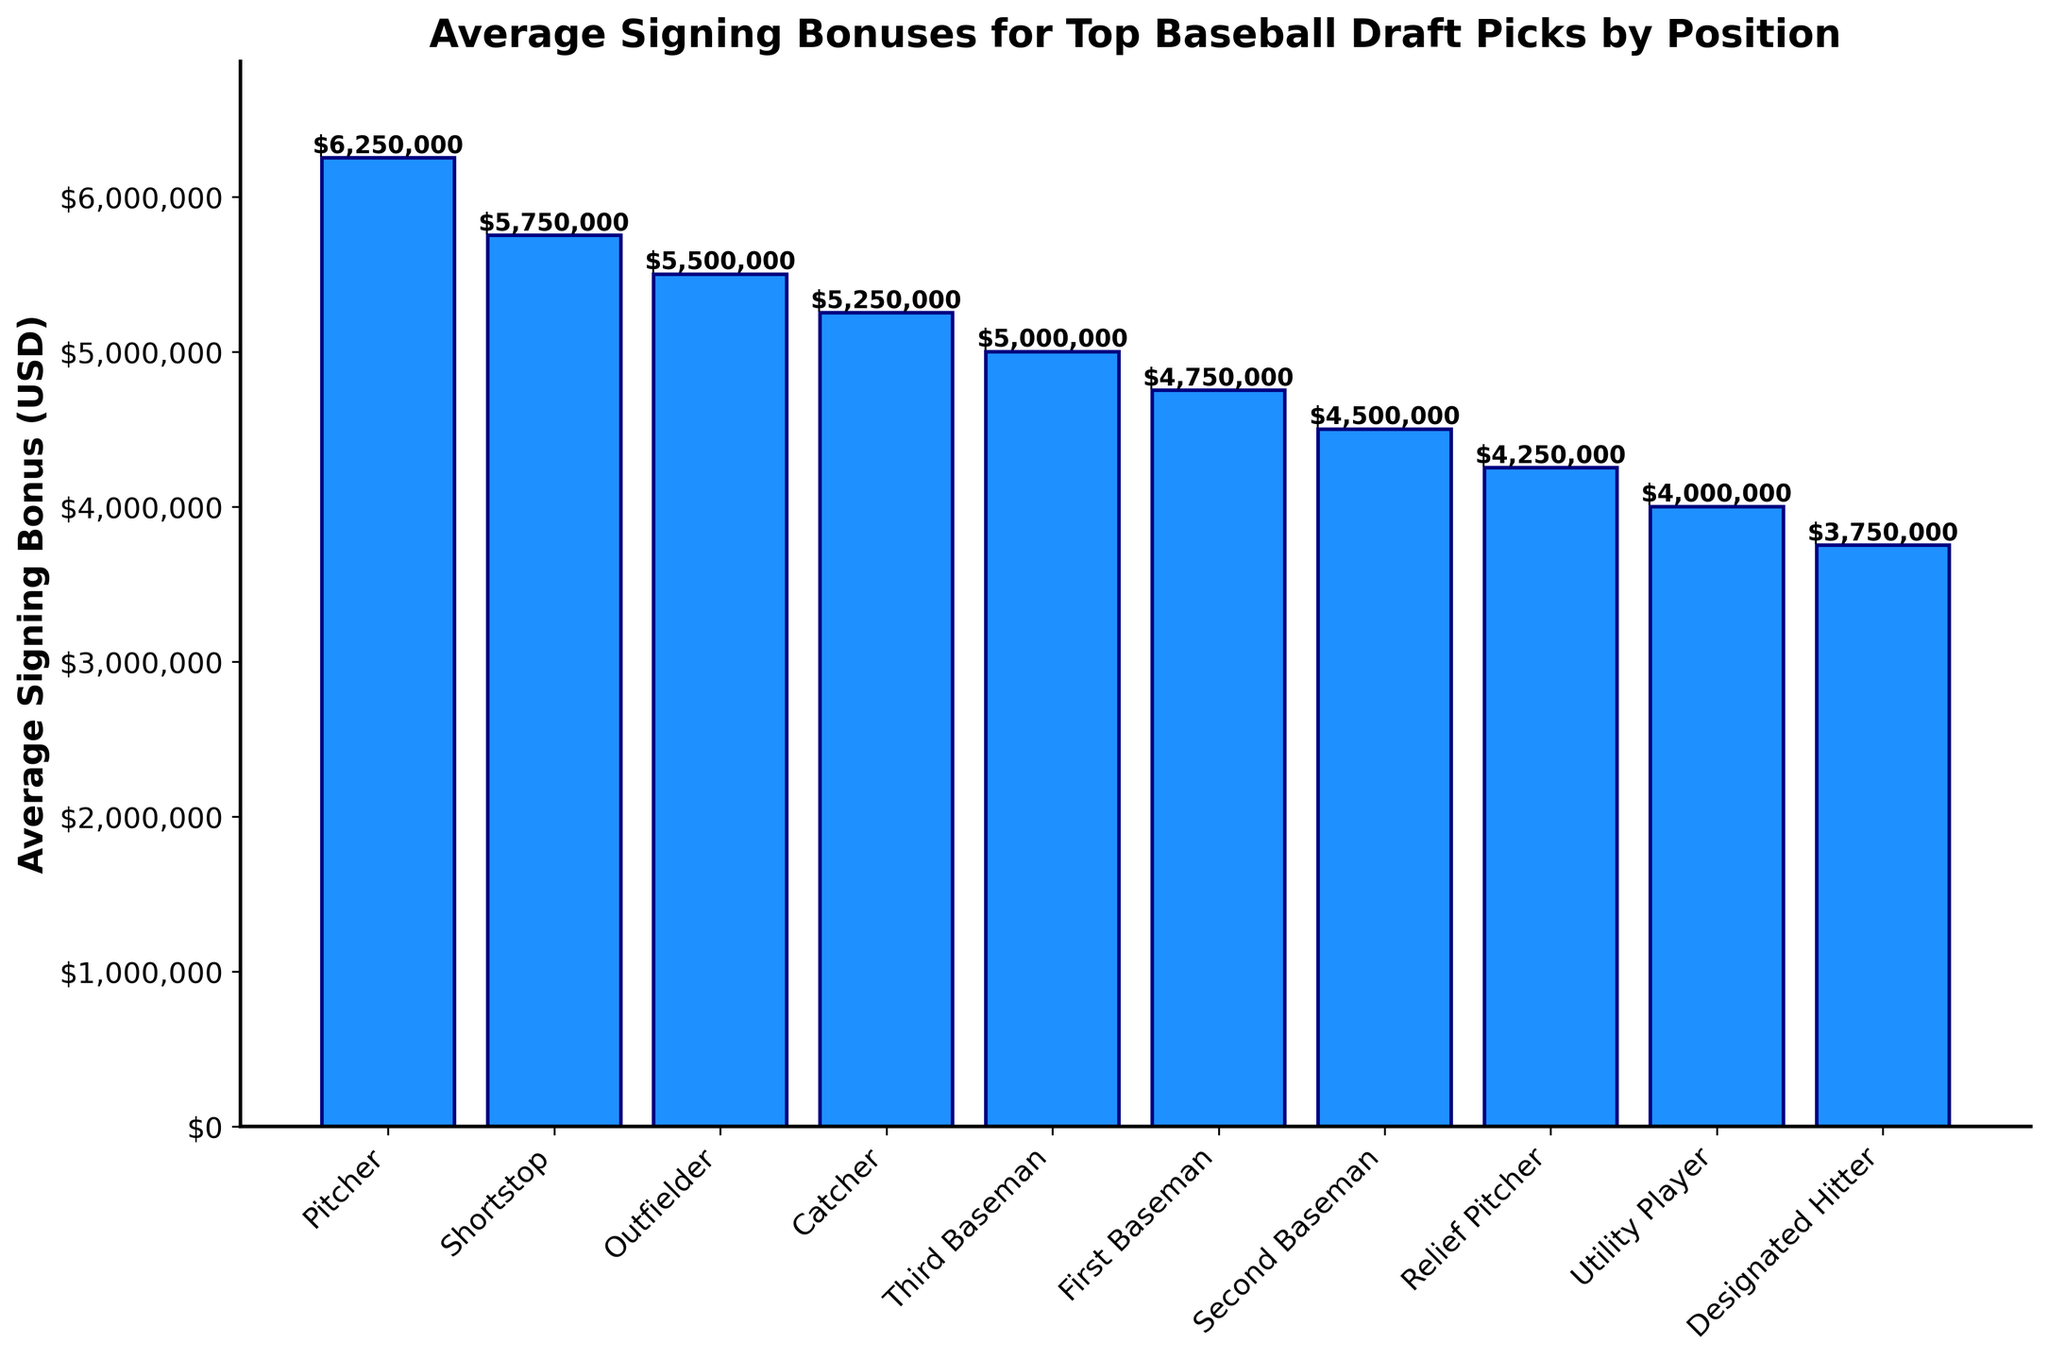Which position has the highest average signing bonus? Examine the height of the bars in the bar chart. The tallest bar represents the position with the highest average signing bonus, which is "Pitcher."
Answer: Pitcher What is the difference in average signing bonuses between Pitchers and Relief Pitchers? Find the bar heights for both Pitcher ($6,250,000) and Relief Pitcher ($4,250,000), then subtract the Relief Pitcher value from the Pitcher value: $6,250,000 - $4,250,000.
Answer: $2,000,000 Which position has a lower average signing bonus, Second Baseman or Third Baseman? Compare the heights of the bars for both positions. The bar representing Second Baseman is lower than that for Third Baseman; therefore, Second Baseman has a lower average signing bonus.
Answer: Second Baseman How many positions have an average signing bonus greater than $5,000,000? Count all the bars with values above $5,000,000. There are three such bars: Pitcher, Shortstop, and Outfielder.
Answer: 3 What is the combined average signing bonus of a Catcher and a First Baseman? Locate the bar heights for Catcher ($5,250,000) and First Baseman ($4,750,000) and add them together: $5,250,000 + $4,750,000.
Answer: $10,000,000 Which position has the smallest average signing bonus? Identify the shortest bar in the chart. The shortest bar represents Designated Hitter at $3,750,000.
Answer: Designated Hitter Are there more infield positions or outfield positions with a signing bonus above $4,500,000? Identify infield (Pitcher, Shortstop, Third Baseman, First Baseman, Second Baseman) and outfield positions (Outfielder, Catcher). Count the number of bars above $4,500,000 in each category. Infield: 3 (Pitcher, Shortstop, Third Baseman) and Outfield: 2 (Outfielder, Catcher).
Answer: Infield positions What is the average signing bonus for the top three positions? Isolate the top three bars (Pitcher $6,250,000, Shortstop $5,750,000, and Outfielder $5,500,000), sum them up, and divide by three: (6,250,000 + 5,750,000 + 5,500,000)/3.
Answer: $5,833,333 How much more is the average signing bonus for Shortstops compared to Utility Players? Find the bar heights for Shortstop ($5,750,000) and Utility Player ($4,000,000) and subtract the Utility Player value from the Shortstop value: $5,750,000 - $4,000,000.
Answer: $1,750,000 